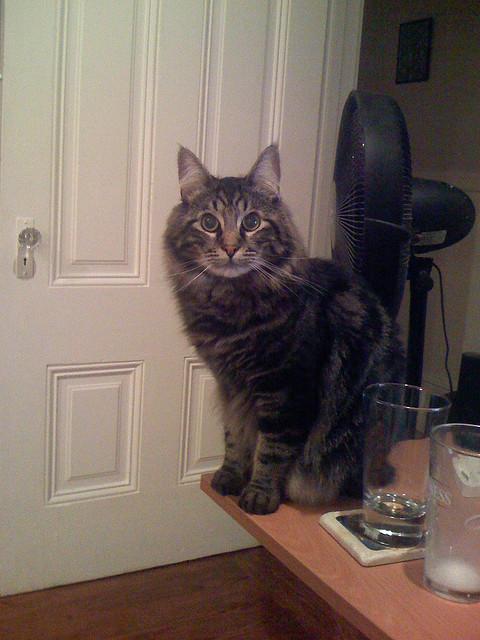What is the  shiny object to the right of the cat?
Quick response, please. Glass. What color is the fan?
Short answer required. Black. What is cat sitting on?
Answer briefly. Table. What is the cat standing on?
Give a very brief answer. Table. Is the kitty wearing a tie?
Be succinct. No. How many glasses are on the table?
Be succinct. 2. Is that a blender in the background?
Keep it brief. No. What is the cat doing?
Quick response, please. Sitting. Does this cat look happy?
Answer briefly. Yes. What is the cat on?
Be succinct. Table. What kind of animal is sitting at the edge of the table?
Concise answer only. Cat. What is the animal sitting on?
Keep it brief. Table. What type of drink is the cat sitting by?
Be succinct. Water. Is the cat sleeping?
Give a very brief answer. No. Is the cat content?
Give a very brief answer. Yes. What is behind the cat?
Short answer required. Door. What color are the pads on the cat's paw?
Concise answer only. Black. What is the cat sitting on?
Answer briefly. Table. What is covering the floor?
Be succinct. Wood. 